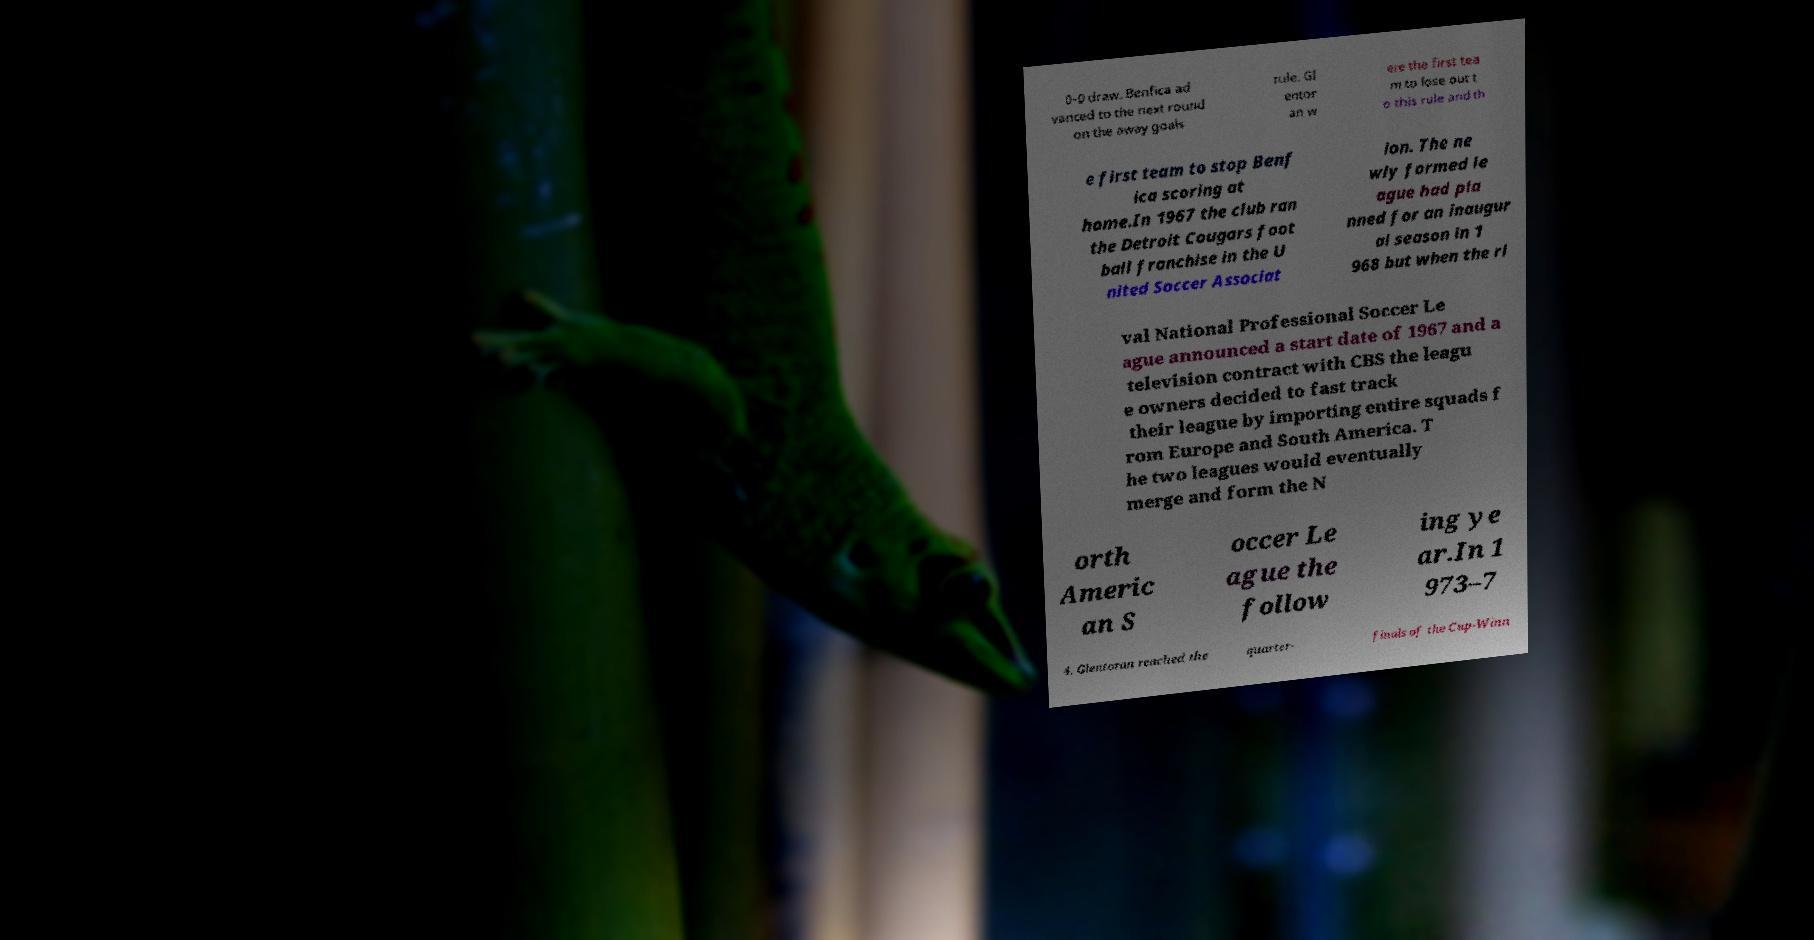Please read and relay the text visible in this image. What does it say? 0–0 draw. Benfica ad vanced to the next round on the away goals rule. Gl entor an w ere the first tea m to lose out t o this rule and th e first team to stop Benf ica scoring at home.In 1967 the club ran the Detroit Cougars foot ball franchise in the U nited Soccer Associat ion. The ne wly formed le ague had pla nned for an inaugur al season in 1 968 but when the ri val National Professional Soccer Le ague announced a start date of 1967 and a television contract with CBS the leagu e owners decided to fast track their league by importing entire squads f rom Europe and South America. T he two leagues would eventually merge and form the N orth Americ an S occer Le ague the follow ing ye ar.In 1 973–7 4, Glentoran reached the quarter- finals of the Cup-Winn 